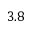<formula> <loc_0><loc_0><loc_500><loc_500>3 . 8</formula> 